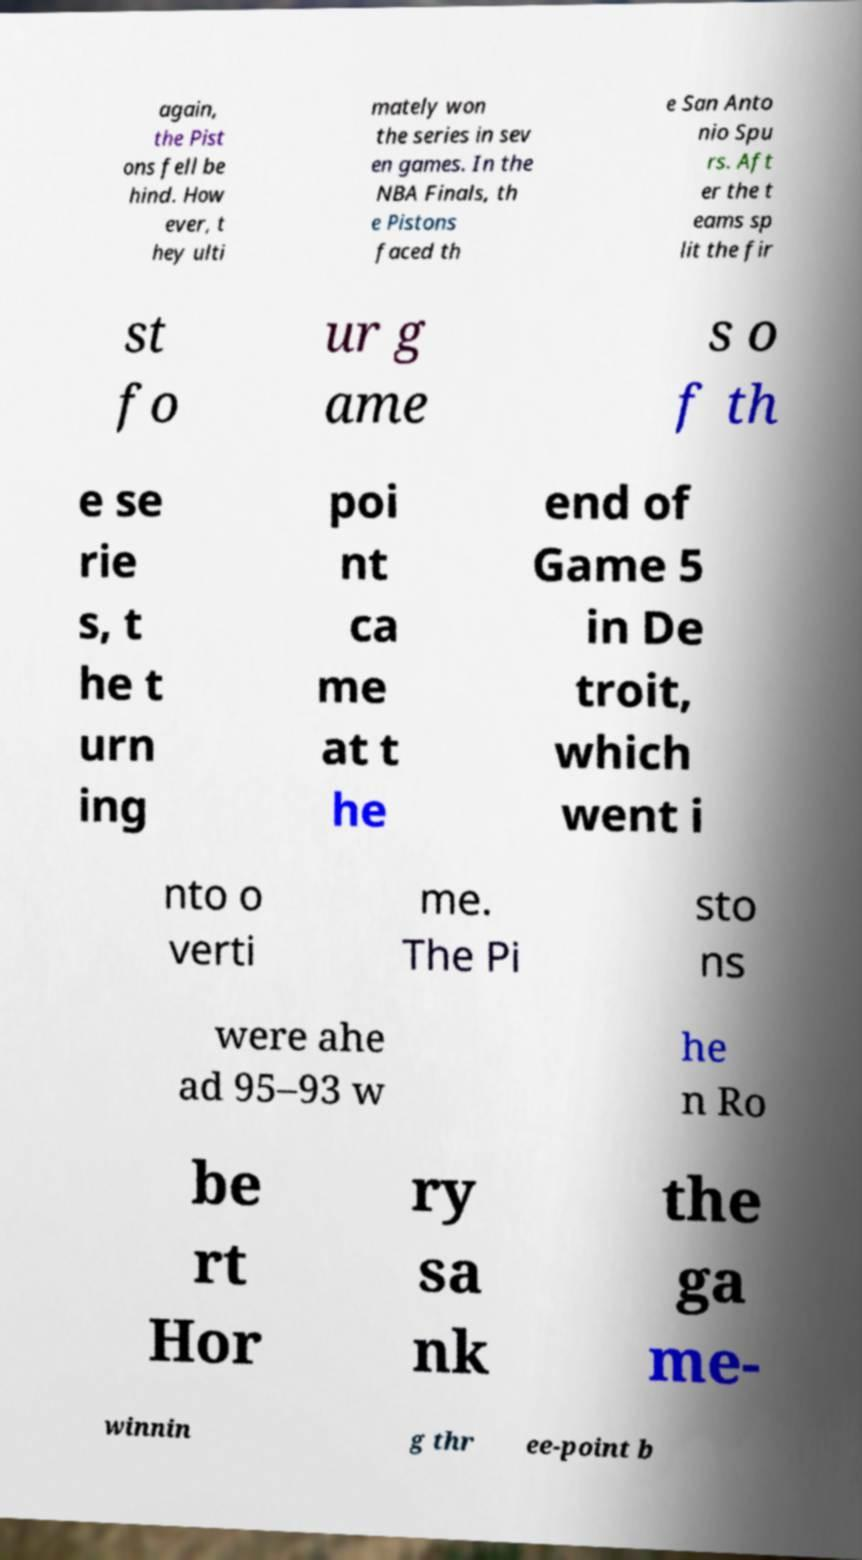Can you accurately transcribe the text from the provided image for me? again, the Pist ons fell be hind. How ever, t hey ulti mately won the series in sev en games. In the NBA Finals, th e Pistons faced th e San Anto nio Spu rs. Aft er the t eams sp lit the fir st fo ur g ame s o f th e se rie s, t he t urn ing poi nt ca me at t he end of Game 5 in De troit, which went i nto o verti me. The Pi sto ns were ahe ad 95–93 w he n Ro be rt Hor ry sa nk the ga me- winnin g thr ee-point b 